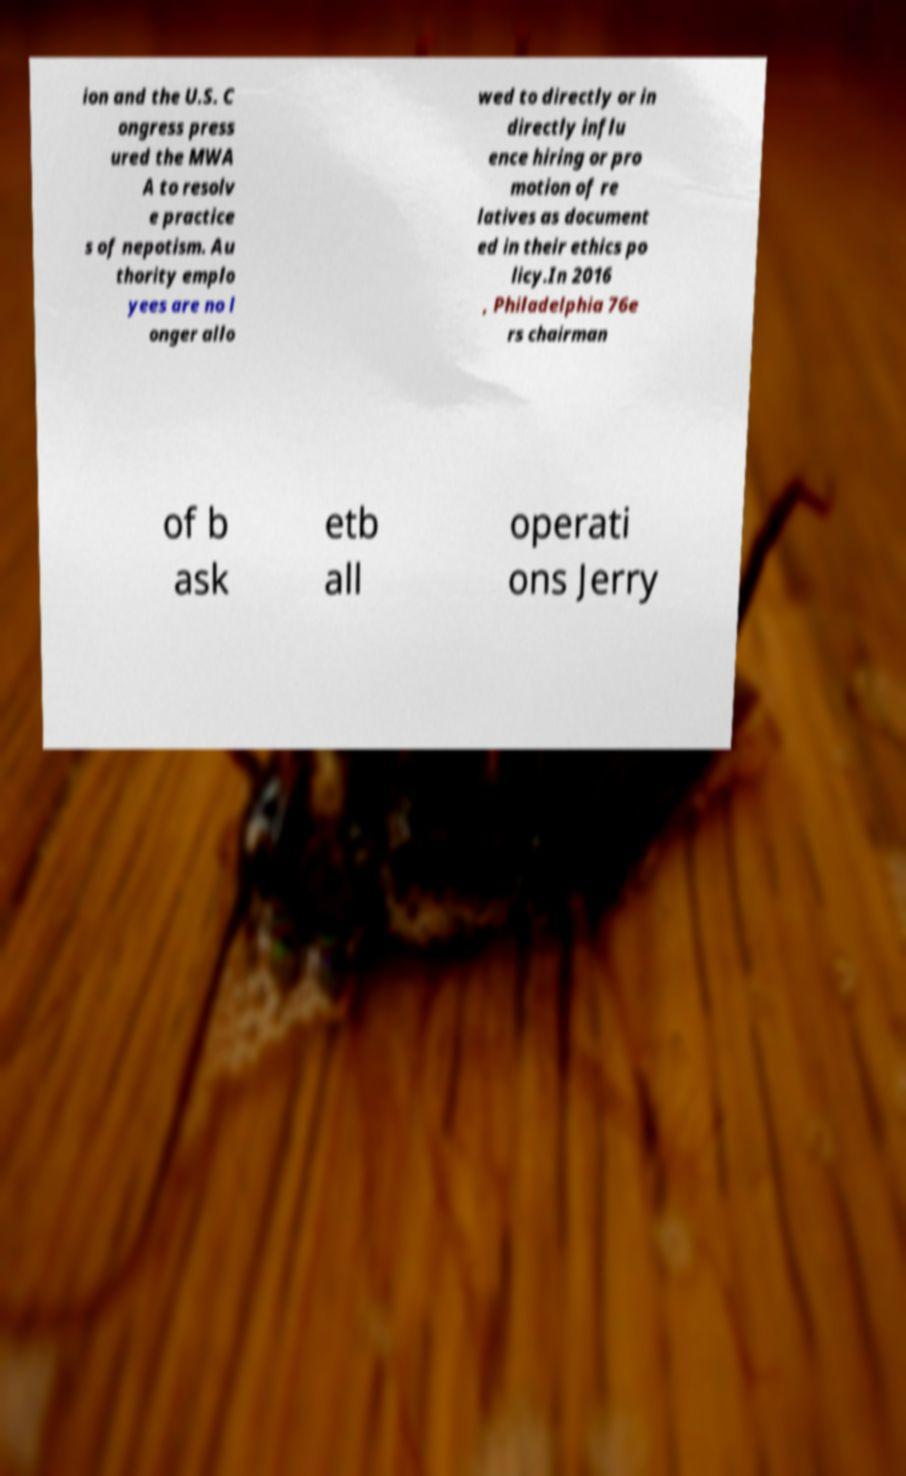I need the written content from this picture converted into text. Can you do that? ion and the U.S. C ongress press ured the MWA A to resolv e practice s of nepotism. Au thority emplo yees are no l onger allo wed to directly or in directly influ ence hiring or pro motion of re latives as document ed in their ethics po licy.In 2016 , Philadelphia 76e rs chairman of b ask etb all operati ons Jerry 